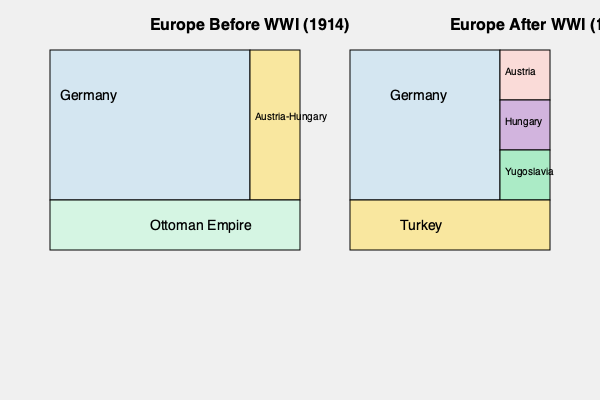Based on the maps showing Europe before and after World War I, which of the following statements best describes the major territorial changes that occurred as a result of the war? To answer this question, we need to analyze the changes in territorial boundaries between the two maps:

1. Germany:
   - Before WWI: Larger territory
   - After WWI: Significantly reduced in size

2. Austria-Hungary:
   - Before WWI: Single, large empire
   - After WWI: Dissolved into separate countries (Austria, Hungary, and part of Yugoslavia)

3. Ottoman Empire:
   - Before WWI: Large territory in southeastern Europe
   - After WWI: Greatly reduced and renamed as Turkey

4. New countries:
   - Yugoslavia appears on the map after WWI

The major changes can be summarized as follows:
a) The dissolution of large empires (Austria-Hungary and Ottoman Empire)
b) The creation of new countries (e.g., Yugoslavia)
c) The reduction of Germany's territory

These changes reflect the outcomes of the Treaty of Versailles and other post-WWI agreements that reshaped Europe's political landscape.
Answer: The dissolution of empires, creation of new nations, and reduction of Germany's territory. 